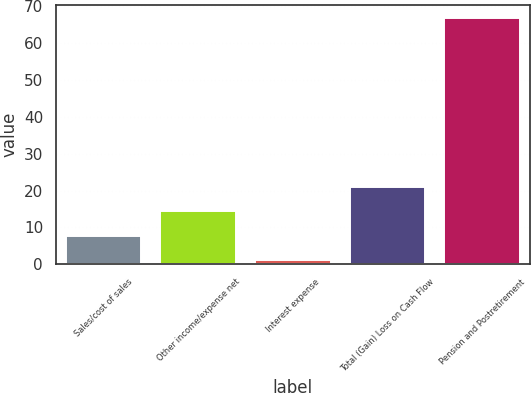Convert chart to OTSL. <chart><loc_0><loc_0><loc_500><loc_500><bar_chart><fcel>Sales/cost of sales<fcel>Other income/expense net<fcel>Interest expense<fcel>Total (Gain) Loss on Cash Flow<fcel>Pension and Postretirement<nl><fcel>7.78<fcel>14.36<fcel>1.2<fcel>20.94<fcel>67<nl></chart> 